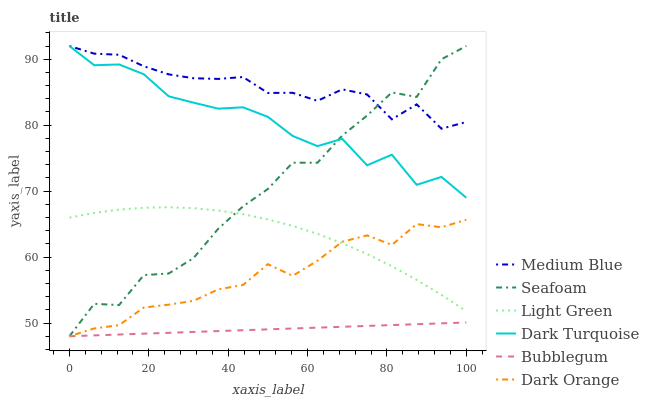Does Bubblegum have the minimum area under the curve?
Answer yes or no. Yes. Does Medium Blue have the maximum area under the curve?
Answer yes or no. Yes. Does Dark Turquoise have the minimum area under the curve?
Answer yes or no. No. Does Dark Turquoise have the maximum area under the curve?
Answer yes or no. No. Is Bubblegum the smoothest?
Answer yes or no. Yes. Is Seafoam the roughest?
Answer yes or no. Yes. Is Dark Turquoise the smoothest?
Answer yes or no. No. Is Dark Turquoise the roughest?
Answer yes or no. No. Does Dark Orange have the lowest value?
Answer yes or no. Yes. Does Dark Turquoise have the lowest value?
Answer yes or no. No. Does Seafoam have the highest value?
Answer yes or no. Yes. Does Bubblegum have the highest value?
Answer yes or no. No. Is Light Green less than Medium Blue?
Answer yes or no. Yes. Is Light Green greater than Bubblegum?
Answer yes or no. Yes. Does Dark Orange intersect Light Green?
Answer yes or no. Yes. Is Dark Orange less than Light Green?
Answer yes or no. No. Is Dark Orange greater than Light Green?
Answer yes or no. No. Does Light Green intersect Medium Blue?
Answer yes or no. No. 